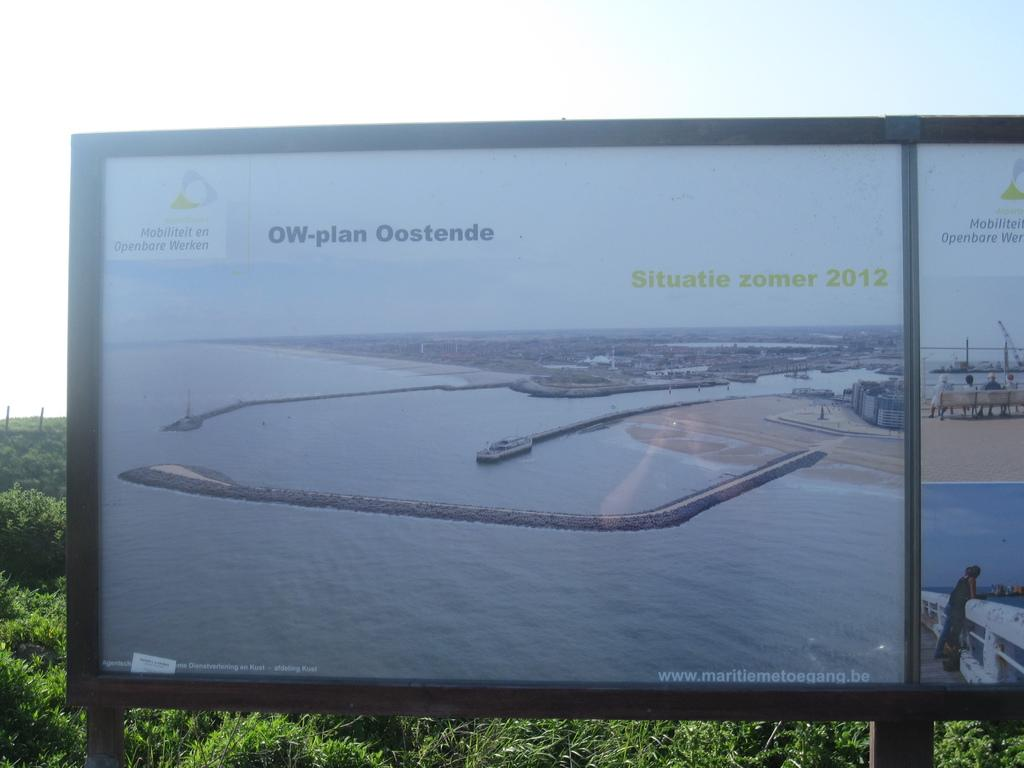What is the main object in the image? There is a board in the image. What can be seen in the background of the image? There are trees and the sky visible in the background of the image. What type of heart-shaped object can be seen on the desk in the image? There is no desk or heart-shaped object present in the image; it only features a board and trees in the background. 